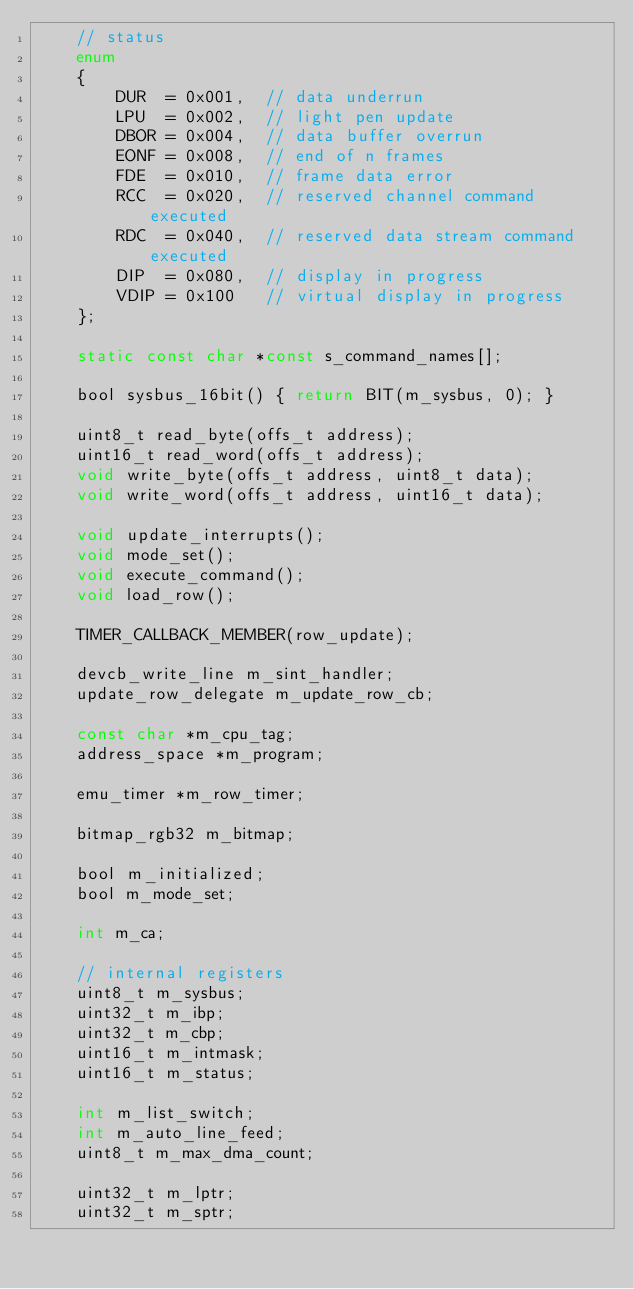<code> <loc_0><loc_0><loc_500><loc_500><_C_>	// status
	enum
	{
		DUR  = 0x001,  // data underrun
		LPU  = 0x002,  // light pen update
		DBOR = 0x004,  // data buffer overrun
		EONF = 0x008,  // end of n frames
		FDE  = 0x010,  // frame data error
		RCC  = 0x020,  // reserved channel command executed
		RDC  = 0x040,  // reserved data stream command executed
		DIP  = 0x080,  // display in progress
		VDIP = 0x100   // virtual display in progress
	};

	static const char *const s_command_names[];

	bool sysbus_16bit() { return BIT(m_sysbus, 0); }

	uint8_t read_byte(offs_t address);
	uint16_t read_word(offs_t address);
	void write_byte(offs_t address, uint8_t data);
	void write_word(offs_t address, uint16_t data);

	void update_interrupts();
	void mode_set();
	void execute_command();
	void load_row();

	TIMER_CALLBACK_MEMBER(row_update);

	devcb_write_line m_sint_handler;
	update_row_delegate m_update_row_cb;

	const char *m_cpu_tag;
	address_space *m_program;

	emu_timer *m_row_timer;

	bitmap_rgb32 m_bitmap;

	bool m_initialized;
	bool m_mode_set;

	int m_ca;

	// internal registers
	uint8_t m_sysbus;
	uint32_t m_ibp;
	uint32_t m_cbp;
	uint16_t m_intmask;
	uint16_t m_status;

	int m_list_switch;
	int m_auto_line_feed;
	uint8_t m_max_dma_count;

	uint32_t m_lptr;
	uint32_t m_sptr;
</code> 